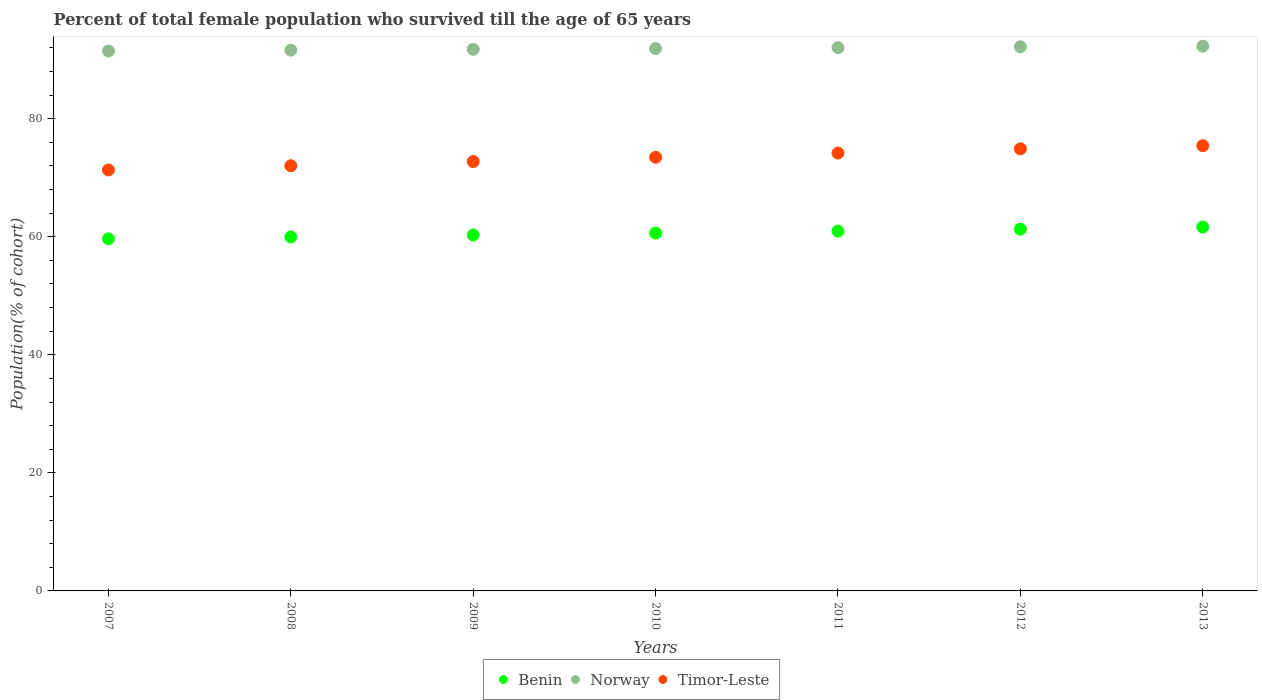What is the percentage of total female population who survived till the age of 65 years in Norway in 2009?
Keep it short and to the point. 91.76. Across all years, what is the maximum percentage of total female population who survived till the age of 65 years in Benin?
Give a very brief answer. 61.65. Across all years, what is the minimum percentage of total female population who survived till the age of 65 years in Norway?
Provide a succinct answer. 91.47. In which year was the percentage of total female population who survived till the age of 65 years in Norway maximum?
Keep it short and to the point. 2013. What is the total percentage of total female population who survived till the age of 65 years in Norway in the graph?
Ensure brevity in your answer.  643.25. What is the difference between the percentage of total female population who survived till the age of 65 years in Norway in 2007 and that in 2012?
Provide a short and direct response. -0.71. What is the difference between the percentage of total female population who survived till the age of 65 years in Benin in 2011 and the percentage of total female population who survived till the age of 65 years in Norway in 2012?
Your answer should be very brief. -31.23. What is the average percentage of total female population who survived till the age of 65 years in Timor-Leste per year?
Ensure brevity in your answer.  73.44. In the year 2008, what is the difference between the percentage of total female population who survived till the age of 65 years in Timor-Leste and percentage of total female population who survived till the age of 65 years in Norway?
Keep it short and to the point. -19.58. What is the ratio of the percentage of total female population who survived till the age of 65 years in Timor-Leste in 2012 to that in 2013?
Offer a terse response. 0.99. Is the difference between the percentage of total female population who survived till the age of 65 years in Timor-Leste in 2009 and 2013 greater than the difference between the percentage of total female population who survived till the age of 65 years in Norway in 2009 and 2013?
Your answer should be very brief. No. What is the difference between the highest and the second highest percentage of total female population who survived till the age of 65 years in Norway?
Your answer should be compact. 0.1. What is the difference between the highest and the lowest percentage of total female population who survived till the age of 65 years in Norway?
Keep it short and to the point. 0.81. Is it the case that in every year, the sum of the percentage of total female population who survived till the age of 65 years in Norway and percentage of total female population who survived till the age of 65 years in Timor-Leste  is greater than the percentage of total female population who survived till the age of 65 years in Benin?
Provide a short and direct response. Yes. Does the percentage of total female population who survived till the age of 65 years in Norway monotonically increase over the years?
Offer a terse response. Yes. Is the percentage of total female population who survived till the age of 65 years in Norway strictly greater than the percentage of total female population who survived till the age of 65 years in Benin over the years?
Your answer should be compact. Yes. Is the percentage of total female population who survived till the age of 65 years in Timor-Leste strictly less than the percentage of total female population who survived till the age of 65 years in Norway over the years?
Provide a succinct answer. Yes. How many dotlines are there?
Your answer should be very brief. 3. Where does the legend appear in the graph?
Provide a succinct answer. Bottom center. What is the title of the graph?
Offer a very short reply. Percent of total female population who survived till the age of 65 years. What is the label or title of the X-axis?
Offer a very short reply. Years. What is the label or title of the Y-axis?
Offer a terse response. Population(% of cohort). What is the Population(% of cohort) in Benin in 2007?
Your answer should be compact. 59.65. What is the Population(% of cohort) of Norway in 2007?
Provide a succinct answer. 91.47. What is the Population(% of cohort) in Timor-Leste in 2007?
Provide a succinct answer. 71.32. What is the Population(% of cohort) of Benin in 2008?
Your response must be concise. 59.98. What is the Population(% of cohort) in Norway in 2008?
Offer a terse response. 91.61. What is the Population(% of cohort) of Timor-Leste in 2008?
Provide a short and direct response. 72.03. What is the Population(% of cohort) in Benin in 2009?
Give a very brief answer. 60.3. What is the Population(% of cohort) in Norway in 2009?
Keep it short and to the point. 91.76. What is the Population(% of cohort) in Timor-Leste in 2009?
Your answer should be very brief. 72.75. What is the Population(% of cohort) of Benin in 2010?
Provide a succinct answer. 60.63. What is the Population(% of cohort) of Norway in 2010?
Your answer should be very brief. 91.9. What is the Population(% of cohort) in Timor-Leste in 2010?
Ensure brevity in your answer.  73.46. What is the Population(% of cohort) of Benin in 2011?
Your response must be concise. 60.95. What is the Population(% of cohort) of Norway in 2011?
Offer a terse response. 92.04. What is the Population(% of cohort) in Timor-Leste in 2011?
Give a very brief answer. 74.18. What is the Population(% of cohort) in Benin in 2012?
Give a very brief answer. 61.28. What is the Population(% of cohort) of Norway in 2012?
Offer a terse response. 92.18. What is the Population(% of cohort) of Timor-Leste in 2012?
Your answer should be compact. 74.9. What is the Population(% of cohort) in Benin in 2013?
Keep it short and to the point. 61.65. What is the Population(% of cohort) in Norway in 2013?
Ensure brevity in your answer.  92.28. What is the Population(% of cohort) in Timor-Leste in 2013?
Offer a very short reply. 75.43. Across all years, what is the maximum Population(% of cohort) in Benin?
Your answer should be very brief. 61.65. Across all years, what is the maximum Population(% of cohort) in Norway?
Your response must be concise. 92.28. Across all years, what is the maximum Population(% of cohort) of Timor-Leste?
Provide a succinct answer. 75.43. Across all years, what is the minimum Population(% of cohort) in Benin?
Ensure brevity in your answer.  59.65. Across all years, what is the minimum Population(% of cohort) of Norway?
Your response must be concise. 91.47. Across all years, what is the minimum Population(% of cohort) of Timor-Leste?
Provide a succinct answer. 71.32. What is the total Population(% of cohort) of Benin in the graph?
Make the answer very short. 424.44. What is the total Population(% of cohort) of Norway in the graph?
Keep it short and to the point. 643.25. What is the total Population(% of cohort) of Timor-Leste in the graph?
Your answer should be compact. 514.07. What is the difference between the Population(% of cohort) in Benin in 2007 and that in 2008?
Provide a succinct answer. -0.33. What is the difference between the Population(% of cohort) in Norway in 2007 and that in 2008?
Make the answer very short. -0.14. What is the difference between the Population(% of cohort) of Timor-Leste in 2007 and that in 2008?
Provide a short and direct response. -0.72. What is the difference between the Population(% of cohort) in Benin in 2007 and that in 2009?
Provide a succinct answer. -0.65. What is the difference between the Population(% of cohort) of Norway in 2007 and that in 2009?
Give a very brief answer. -0.28. What is the difference between the Population(% of cohort) in Timor-Leste in 2007 and that in 2009?
Offer a very short reply. -1.43. What is the difference between the Population(% of cohort) of Benin in 2007 and that in 2010?
Your answer should be very brief. -0.98. What is the difference between the Population(% of cohort) of Norway in 2007 and that in 2010?
Provide a succinct answer. -0.43. What is the difference between the Population(% of cohort) of Timor-Leste in 2007 and that in 2010?
Give a very brief answer. -2.15. What is the difference between the Population(% of cohort) of Benin in 2007 and that in 2011?
Offer a very short reply. -1.3. What is the difference between the Population(% of cohort) in Norway in 2007 and that in 2011?
Make the answer very short. -0.57. What is the difference between the Population(% of cohort) of Timor-Leste in 2007 and that in 2011?
Ensure brevity in your answer.  -2.87. What is the difference between the Population(% of cohort) of Benin in 2007 and that in 2012?
Your response must be concise. -1.63. What is the difference between the Population(% of cohort) of Norway in 2007 and that in 2012?
Make the answer very short. -0.71. What is the difference between the Population(% of cohort) of Timor-Leste in 2007 and that in 2012?
Ensure brevity in your answer.  -3.58. What is the difference between the Population(% of cohort) of Benin in 2007 and that in 2013?
Keep it short and to the point. -2. What is the difference between the Population(% of cohort) of Norway in 2007 and that in 2013?
Keep it short and to the point. -0.81. What is the difference between the Population(% of cohort) in Timor-Leste in 2007 and that in 2013?
Provide a short and direct response. -4.11. What is the difference between the Population(% of cohort) of Benin in 2008 and that in 2009?
Your answer should be very brief. -0.33. What is the difference between the Population(% of cohort) of Norway in 2008 and that in 2009?
Make the answer very short. -0.14. What is the difference between the Population(% of cohort) of Timor-Leste in 2008 and that in 2009?
Make the answer very short. -0.72. What is the difference between the Population(% of cohort) of Benin in 2008 and that in 2010?
Provide a succinct answer. -0.65. What is the difference between the Population(% of cohort) of Norway in 2008 and that in 2010?
Keep it short and to the point. -0.28. What is the difference between the Population(% of cohort) in Timor-Leste in 2008 and that in 2010?
Ensure brevity in your answer.  -1.43. What is the difference between the Population(% of cohort) in Benin in 2008 and that in 2011?
Provide a succinct answer. -0.98. What is the difference between the Population(% of cohort) in Norway in 2008 and that in 2011?
Ensure brevity in your answer.  -0.43. What is the difference between the Population(% of cohort) of Timor-Leste in 2008 and that in 2011?
Provide a succinct answer. -2.15. What is the difference between the Population(% of cohort) of Benin in 2008 and that in 2012?
Offer a very short reply. -1.3. What is the difference between the Population(% of cohort) of Norway in 2008 and that in 2012?
Make the answer very short. -0.57. What is the difference between the Population(% of cohort) in Timor-Leste in 2008 and that in 2012?
Your answer should be compact. -2.87. What is the difference between the Population(% of cohort) of Benin in 2008 and that in 2013?
Offer a very short reply. -1.67. What is the difference between the Population(% of cohort) in Norway in 2008 and that in 2013?
Offer a very short reply. -0.67. What is the difference between the Population(% of cohort) of Timor-Leste in 2008 and that in 2013?
Your response must be concise. -3.4. What is the difference between the Population(% of cohort) of Benin in 2009 and that in 2010?
Provide a short and direct response. -0.33. What is the difference between the Population(% of cohort) of Norway in 2009 and that in 2010?
Provide a short and direct response. -0.14. What is the difference between the Population(% of cohort) of Timor-Leste in 2009 and that in 2010?
Provide a succinct answer. -0.72. What is the difference between the Population(% of cohort) of Benin in 2009 and that in 2011?
Provide a short and direct response. -0.65. What is the difference between the Population(% of cohort) in Norway in 2009 and that in 2011?
Your answer should be very brief. -0.28. What is the difference between the Population(% of cohort) of Timor-Leste in 2009 and that in 2011?
Your answer should be very brief. -1.43. What is the difference between the Population(% of cohort) of Benin in 2009 and that in 2012?
Offer a terse response. -0.98. What is the difference between the Population(% of cohort) of Norway in 2009 and that in 2012?
Keep it short and to the point. -0.43. What is the difference between the Population(% of cohort) of Timor-Leste in 2009 and that in 2012?
Offer a terse response. -2.15. What is the difference between the Population(% of cohort) in Benin in 2009 and that in 2013?
Make the answer very short. -1.34. What is the difference between the Population(% of cohort) of Norway in 2009 and that in 2013?
Give a very brief answer. -0.53. What is the difference between the Population(% of cohort) of Timor-Leste in 2009 and that in 2013?
Provide a short and direct response. -2.68. What is the difference between the Population(% of cohort) of Benin in 2010 and that in 2011?
Your response must be concise. -0.33. What is the difference between the Population(% of cohort) in Norway in 2010 and that in 2011?
Provide a succinct answer. -0.14. What is the difference between the Population(% of cohort) in Timor-Leste in 2010 and that in 2011?
Offer a very short reply. -0.72. What is the difference between the Population(% of cohort) of Benin in 2010 and that in 2012?
Offer a very short reply. -0.65. What is the difference between the Population(% of cohort) in Norway in 2010 and that in 2012?
Your answer should be very brief. -0.28. What is the difference between the Population(% of cohort) in Timor-Leste in 2010 and that in 2012?
Your answer should be compact. -1.43. What is the difference between the Population(% of cohort) of Benin in 2010 and that in 2013?
Give a very brief answer. -1.02. What is the difference between the Population(% of cohort) of Norway in 2010 and that in 2013?
Your response must be concise. -0.39. What is the difference between the Population(% of cohort) of Timor-Leste in 2010 and that in 2013?
Make the answer very short. -1.96. What is the difference between the Population(% of cohort) in Benin in 2011 and that in 2012?
Make the answer very short. -0.33. What is the difference between the Population(% of cohort) in Norway in 2011 and that in 2012?
Provide a succinct answer. -0.14. What is the difference between the Population(% of cohort) in Timor-Leste in 2011 and that in 2012?
Offer a very short reply. -0.72. What is the difference between the Population(% of cohort) in Benin in 2011 and that in 2013?
Ensure brevity in your answer.  -0.69. What is the difference between the Population(% of cohort) of Norway in 2011 and that in 2013?
Offer a terse response. -0.24. What is the difference between the Population(% of cohort) of Timor-Leste in 2011 and that in 2013?
Ensure brevity in your answer.  -1.25. What is the difference between the Population(% of cohort) in Benin in 2012 and that in 2013?
Keep it short and to the point. -0.37. What is the difference between the Population(% of cohort) of Norway in 2012 and that in 2013?
Give a very brief answer. -0.1. What is the difference between the Population(% of cohort) of Timor-Leste in 2012 and that in 2013?
Provide a succinct answer. -0.53. What is the difference between the Population(% of cohort) in Benin in 2007 and the Population(% of cohort) in Norway in 2008?
Ensure brevity in your answer.  -31.96. What is the difference between the Population(% of cohort) of Benin in 2007 and the Population(% of cohort) of Timor-Leste in 2008?
Provide a succinct answer. -12.38. What is the difference between the Population(% of cohort) of Norway in 2007 and the Population(% of cohort) of Timor-Leste in 2008?
Your answer should be compact. 19.44. What is the difference between the Population(% of cohort) in Benin in 2007 and the Population(% of cohort) in Norway in 2009?
Provide a short and direct response. -32.11. What is the difference between the Population(% of cohort) of Benin in 2007 and the Population(% of cohort) of Timor-Leste in 2009?
Provide a succinct answer. -13.1. What is the difference between the Population(% of cohort) in Norway in 2007 and the Population(% of cohort) in Timor-Leste in 2009?
Your response must be concise. 18.72. What is the difference between the Population(% of cohort) of Benin in 2007 and the Population(% of cohort) of Norway in 2010?
Give a very brief answer. -32.25. What is the difference between the Population(% of cohort) of Benin in 2007 and the Population(% of cohort) of Timor-Leste in 2010?
Ensure brevity in your answer.  -13.81. What is the difference between the Population(% of cohort) in Norway in 2007 and the Population(% of cohort) in Timor-Leste in 2010?
Your answer should be very brief. 18.01. What is the difference between the Population(% of cohort) in Benin in 2007 and the Population(% of cohort) in Norway in 2011?
Provide a succinct answer. -32.39. What is the difference between the Population(% of cohort) of Benin in 2007 and the Population(% of cohort) of Timor-Leste in 2011?
Provide a short and direct response. -14.53. What is the difference between the Population(% of cohort) of Norway in 2007 and the Population(% of cohort) of Timor-Leste in 2011?
Your answer should be compact. 17.29. What is the difference between the Population(% of cohort) of Benin in 2007 and the Population(% of cohort) of Norway in 2012?
Your response must be concise. -32.53. What is the difference between the Population(% of cohort) of Benin in 2007 and the Population(% of cohort) of Timor-Leste in 2012?
Your answer should be compact. -15.25. What is the difference between the Population(% of cohort) of Norway in 2007 and the Population(% of cohort) of Timor-Leste in 2012?
Your answer should be very brief. 16.57. What is the difference between the Population(% of cohort) in Benin in 2007 and the Population(% of cohort) in Norway in 2013?
Your answer should be very brief. -32.63. What is the difference between the Population(% of cohort) of Benin in 2007 and the Population(% of cohort) of Timor-Leste in 2013?
Make the answer very short. -15.78. What is the difference between the Population(% of cohort) in Norway in 2007 and the Population(% of cohort) in Timor-Leste in 2013?
Provide a short and direct response. 16.04. What is the difference between the Population(% of cohort) of Benin in 2008 and the Population(% of cohort) of Norway in 2009?
Provide a short and direct response. -31.78. What is the difference between the Population(% of cohort) in Benin in 2008 and the Population(% of cohort) in Timor-Leste in 2009?
Your answer should be compact. -12.77. What is the difference between the Population(% of cohort) in Norway in 2008 and the Population(% of cohort) in Timor-Leste in 2009?
Your response must be concise. 18.87. What is the difference between the Population(% of cohort) of Benin in 2008 and the Population(% of cohort) of Norway in 2010?
Offer a terse response. -31.92. What is the difference between the Population(% of cohort) of Benin in 2008 and the Population(% of cohort) of Timor-Leste in 2010?
Offer a very short reply. -13.49. What is the difference between the Population(% of cohort) of Norway in 2008 and the Population(% of cohort) of Timor-Leste in 2010?
Provide a succinct answer. 18.15. What is the difference between the Population(% of cohort) of Benin in 2008 and the Population(% of cohort) of Norway in 2011?
Your response must be concise. -32.06. What is the difference between the Population(% of cohort) of Benin in 2008 and the Population(% of cohort) of Timor-Leste in 2011?
Provide a succinct answer. -14.21. What is the difference between the Population(% of cohort) in Norway in 2008 and the Population(% of cohort) in Timor-Leste in 2011?
Your answer should be very brief. 17.43. What is the difference between the Population(% of cohort) in Benin in 2008 and the Population(% of cohort) in Norway in 2012?
Keep it short and to the point. -32.21. What is the difference between the Population(% of cohort) of Benin in 2008 and the Population(% of cohort) of Timor-Leste in 2012?
Offer a very short reply. -14.92. What is the difference between the Population(% of cohort) of Norway in 2008 and the Population(% of cohort) of Timor-Leste in 2012?
Your answer should be compact. 16.72. What is the difference between the Population(% of cohort) of Benin in 2008 and the Population(% of cohort) of Norway in 2013?
Your answer should be compact. -32.31. What is the difference between the Population(% of cohort) of Benin in 2008 and the Population(% of cohort) of Timor-Leste in 2013?
Offer a terse response. -15.45. What is the difference between the Population(% of cohort) of Norway in 2008 and the Population(% of cohort) of Timor-Leste in 2013?
Provide a short and direct response. 16.19. What is the difference between the Population(% of cohort) in Benin in 2009 and the Population(% of cohort) in Norway in 2010?
Offer a terse response. -31.6. What is the difference between the Population(% of cohort) in Benin in 2009 and the Population(% of cohort) in Timor-Leste in 2010?
Your answer should be very brief. -13.16. What is the difference between the Population(% of cohort) of Norway in 2009 and the Population(% of cohort) of Timor-Leste in 2010?
Ensure brevity in your answer.  18.29. What is the difference between the Population(% of cohort) of Benin in 2009 and the Population(% of cohort) of Norway in 2011?
Make the answer very short. -31.74. What is the difference between the Population(% of cohort) in Benin in 2009 and the Population(% of cohort) in Timor-Leste in 2011?
Ensure brevity in your answer.  -13.88. What is the difference between the Population(% of cohort) of Norway in 2009 and the Population(% of cohort) of Timor-Leste in 2011?
Give a very brief answer. 17.57. What is the difference between the Population(% of cohort) of Benin in 2009 and the Population(% of cohort) of Norway in 2012?
Your response must be concise. -31.88. What is the difference between the Population(% of cohort) in Benin in 2009 and the Population(% of cohort) in Timor-Leste in 2012?
Provide a succinct answer. -14.6. What is the difference between the Population(% of cohort) in Norway in 2009 and the Population(% of cohort) in Timor-Leste in 2012?
Keep it short and to the point. 16.86. What is the difference between the Population(% of cohort) of Benin in 2009 and the Population(% of cohort) of Norway in 2013?
Your response must be concise. -31.98. What is the difference between the Population(% of cohort) in Benin in 2009 and the Population(% of cohort) in Timor-Leste in 2013?
Give a very brief answer. -15.13. What is the difference between the Population(% of cohort) in Norway in 2009 and the Population(% of cohort) in Timor-Leste in 2013?
Make the answer very short. 16.33. What is the difference between the Population(% of cohort) of Benin in 2010 and the Population(% of cohort) of Norway in 2011?
Make the answer very short. -31.41. What is the difference between the Population(% of cohort) of Benin in 2010 and the Population(% of cohort) of Timor-Leste in 2011?
Your answer should be very brief. -13.55. What is the difference between the Population(% of cohort) in Norway in 2010 and the Population(% of cohort) in Timor-Leste in 2011?
Ensure brevity in your answer.  17.72. What is the difference between the Population(% of cohort) of Benin in 2010 and the Population(% of cohort) of Norway in 2012?
Offer a terse response. -31.55. What is the difference between the Population(% of cohort) of Benin in 2010 and the Population(% of cohort) of Timor-Leste in 2012?
Keep it short and to the point. -14.27. What is the difference between the Population(% of cohort) of Norway in 2010 and the Population(% of cohort) of Timor-Leste in 2012?
Your answer should be very brief. 17. What is the difference between the Population(% of cohort) in Benin in 2010 and the Population(% of cohort) in Norway in 2013?
Your answer should be very brief. -31.66. What is the difference between the Population(% of cohort) in Benin in 2010 and the Population(% of cohort) in Timor-Leste in 2013?
Provide a succinct answer. -14.8. What is the difference between the Population(% of cohort) of Norway in 2010 and the Population(% of cohort) of Timor-Leste in 2013?
Your response must be concise. 16.47. What is the difference between the Population(% of cohort) of Benin in 2011 and the Population(% of cohort) of Norway in 2012?
Provide a succinct answer. -31.23. What is the difference between the Population(% of cohort) of Benin in 2011 and the Population(% of cohort) of Timor-Leste in 2012?
Offer a terse response. -13.94. What is the difference between the Population(% of cohort) of Norway in 2011 and the Population(% of cohort) of Timor-Leste in 2012?
Keep it short and to the point. 17.14. What is the difference between the Population(% of cohort) of Benin in 2011 and the Population(% of cohort) of Norway in 2013?
Your response must be concise. -31.33. What is the difference between the Population(% of cohort) in Benin in 2011 and the Population(% of cohort) in Timor-Leste in 2013?
Give a very brief answer. -14.47. What is the difference between the Population(% of cohort) in Norway in 2011 and the Population(% of cohort) in Timor-Leste in 2013?
Provide a succinct answer. 16.61. What is the difference between the Population(% of cohort) in Benin in 2012 and the Population(% of cohort) in Norway in 2013?
Offer a very short reply. -31. What is the difference between the Population(% of cohort) of Benin in 2012 and the Population(% of cohort) of Timor-Leste in 2013?
Keep it short and to the point. -14.15. What is the difference between the Population(% of cohort) of Norway in 2012 and the Population(% of cohort) of Timor-Leste in 2013?
Keep it short and to the point. 16.75. What is the average Population(% of cohort) of Benin per year?
Offer a very short reply. 60.63. What is the average Population(% of cohort) in Norway per year?
Your answer should be very brief. 91.89. What is the average Population(% of cohort) of Timor-Leste per year?
Your answer should be compact. 73.44. In the year 2007, what is the difference between the Population(% of cohort) of Benin and Population(% of cohort) of Norway?
Your response must be concise. -31.82. In the year 2007, what is the difference between the Population(% of cohort) of Benin and Population(% of cohort) of Timor-Leste?
Provide a short and direct response. -11.67. In the year 2007, what is the difference between the Population(% of cohort) of Norway and Population(% of cohort) of Timor-Leste?
Provide a succinct answer. 20.16. In the year 2008, what is the difference between the Population(% of cohort) in Benin and Population(% of cohort) in Norway?
Offer a terse response. -31.64. In the year 2008, what is the difference between the Population(% of cohort) in Benin and Population(% of cohort) in Timor-Leste?
Give a very brief answer. -12.06. In the year 2008, what is the difference between the Population(% of cohort) in Norway and Population(% of cohort) in Timor-Leste?
Offer a terse response. 19.58. In the year 2009, what is the difference between the Population(% of cohort) in Benin and Population(% of cohort) in Norway?
Offer a very short reply. -31.45. In the year 2009, what is the difference between the Population(% of cohort) in Benin and Population(% of cohort) in Timor-Leste?
Keep it short and to the point. -12.45. In the year 2009, what is the difference between the Population(% of cohort) of Norway and Population(% of cohort) of Timor-Leste?
Make the answer very short. 19.01. In the year 2010, what is the difference between the Population(% of cohort) in Benin and Population(% of cohort) in Norway?
Ensure brevity in your answer.  -31.27. In the year 2010, what is the difference between the Population(% of cohort) in Benin and Population(% of cohort) in Timor-Leste?
Offer a very short reply. -12.84. In the year 2010, what is the difference between the Population(% of cohort) of Norway and Population(% of cohort) of Timor-Leste?
Your response must be concise. 18.43. In the year 2011, what is the difference between the Population(% of cohort) of Benin and Population(% of cohort) of Norway?
Your answer should be very brief. -31.09. In the year 2011, what is the difference between the Population(% of cohort) in Benin and Population(% of cohort) in Timor-Leste?
Your answer should be very brief. -13.23. In the year 2011, what is the difference between the Population(% of cohort) of Norway and Population(% of cohort) of Timor-Leste?
Provide a succinct answer. 17.86. In the year 2012, what is the difference between the Population(% of cohort) of Benin and Population(% of cohort) of Norway?
Provide a short and direct response. -30.9. In the year 2012, what is the difference between the Population(% of cohort) of Benin and Population(% of cohort) of Timor-Leste?
Keep it short and to the point. -13.62. In the year 2012, what is the difference between the Population(% of cohort) in Norway and Population(% of cohort) in Timor-Leste?
Your response must be concise. 17.29. In the year 2013, what is the difference between the Population(% of cohort) of Benin and Population(% of cohort) of Norway?
Give a very brief answer. -30.64. In the year 2013, what is the difference between the Population(% of cohort) in Benin and Population(% of cohort) in Timor-Leste?
Offer a very short reply. -13.78. In the year 2013, what is the difference between the Population(% of cohort) of Norway and Population(% of cohort) of Timor-Leste?
Your answer should be very brief. 16.86. What is the ratio of the Population(% of cohort) in Benin in 2007 to that in 2009?
Ensure brevity in your answer.  0.99. What is the ratio of the Population(% of cohort) of Norway in 2007 to that in 2009?
Your answer should be compact. 1. What is the ratio of the Population(% of cohort) of Timor-Leste in 2007 to that in 2009?
Give a very brief answer. 0.98. What is the ratio of the Population(% of cohort) of Benin in 2007 to that in 2010?
Offer a terse response. 0.98. What is the ratio of the Population(% of cohort) of Timor-Leste in 2007 to that in 2010?
Give a very brief answer. 0.97. What is the ratio of the Population(% of cohort) of Benin in 2007 to that in 2011?
Your answer should be very brief. 0.98. What is the ratio of the Population(% of cohort) of Timor-Leste in 2007 to that in 2011?
Your answer should be compact. 0.96. What is the ratio of the Population(% of cohort) in Benin in 2007 to that in 2012?
Offer a very short reply. 0.97. What is the ratio of the Population(% of cohort) in Timor-Leste in 2007 to that in 2012?
Provide a short and direct response. 0.95. What is the ratio of the Population(% of cohort) of Benin in 2007 to that in 2013?
Your answer should be compact. 0.97. What is the ratio of the Population(% of cohort) in Timor-Leste in 2007 to that in 2013?
Offer a very short reply. 0.95. What is the ratio of the Population(% of cohort) in Timor-Leste in 2008 to that in 2009?
Ensure brevity in your answer.  0.99. What is the ratio of the Population(% of cohort) of Timor-Leste in 2008 to that in 2010?
Your answer should be very brief. 0.98. What is the ratio of the Population(% of cohort) in Timor-Leste in 2008 to that in 2011?
Your answer should be compact. 0.97. What is the ratio of the Population(% of cohort) in Benin in 2008 to that in 2012?
Provide a succinct answer. 0.98. What is the ratio of the Population(% of cohort) of Norway in 2008 to that in 2012?
Make the answer very short. 0.99. What is the ratio of the Population(% of cohort) in Timor-Leste in 2008 to that in 2012?
Offer a terse response. 0.96. What is the ratio of the Population(% of cohort) of Benin in 2008 to that in 2013?
Provide a short and direct response. 0.97. What is the ratio of the Population(% of cohort) of Norway in 2008 to that in 2013?
Make the answer very short. 0.99. What is the ratio of the Population(% of cohort) in Timor-Leste in 2008 to that in 2013?
Give a very brief answer. 0.95. What is the ratio of the Population(% of cohort) of Benin in 2009 to that in 2010?
Give a very brief answer. 0.99. What is the ratio of the Population(% of cohort) in Norway in 2009 to that in 2010?
Provide a short and direct response. 1. What is the ratio of the Population(% of cohort) of Timor-Leste in 2009 to that in 2010?
Make the answer very short. 0.99. What is the ratio of the Population(% of cohort) in Benin in 2009 to that in 2011?
Keep it short and to the point. 0.99. What is the ratio of the Population(% of cohort) in Timor-Leste in 2009 to that in 2011?
Provide a succinct answer. 0.98. What is the ratio of the Population(% of cohort) in Norway in 2009 to that in 2012?
Ensure brevity in your answer.  1. What is the ratio of the Population(% of cohort) of Timor-Leste in 2009 to that in 2012?
Offer a terse response. 0.97. What is the ratio of the Population(% of cohort) in Benin in 2009 to that in 2013?
Ensure brevity in your answer.  0.98. What is the ratio of the Population(% of cohort) in Timor-Leste in 2009 to that in 2013?
Offer a very short reply. 0.96. What is the ratio of the Population(% of cohort) in Benin in 2010 to that in 2011?
Provide a short and direct response. 0.99. What is the ratio of the Population(% of cohort) in Timor-Leste in 2010 to that in 2011?
Offer a very short reply. 0.99. What is the ratio of the Population(% of cohort) in Norway in 2010 to that in 2012?
Give a very brief answer. 1. What is the ratio of the Population(% of cohort) in Timor-Leste in 2010 to that in 2012?
Provide a succinct answer. 0.98. What is the ratio of the Population(% of cohort) in Benin in 2010 to that in 2013?
Offer a terse response. 0.98. What is the ratio of the Population(% of cohort) of Norway in 2010 to that in 2013?
Keep it short and to the point. 1. What is the ratio of the Population(% of cohort) of Timor-Leste in 2010 to that in 2013?
Your answer should be very brief. 0.97. What is the ratio of the Population(% of cohort) of Benin in 2011 to that in 2012?
Give a very brief answer. 0.99. What is the ratio of the Population(% of cohort) of Benin in 2011 to that in 2013?
Make the answer very short. 0.99. What is the ratio of the Population(% of cohort) of Timor-Leste in 2011 to that in 2013?
Your answer should be very brief. 0.98. What is the ratio of the Population(% of cohort) in Benin in 2012 to that in 2013?
Ensure brevity in your answer.  0.99. What is the difference between the highest and the second highest Population(% of cohort) of Benin?
Offer a terse response. 0.37. What is the difference between the highest and the second highest Population(% of cohort) of Norway?
Offer a very short reply. 0.1. What is the difference between the highest and the second highest Population(% of cohort) in Timor-Leste?
Provide a short and direct response. 0.53. What is the difference between the highest and the lowest Population(% of cohort) of Benin?
Keep it short and to the point. 2. What is the difference between the highest and the lowest Population(% of cohort) of Norway?
Provide a short and direct response. 0.81. What is the difference between the highest and the lowest Population(% of cohort) of Timor-Leste?
Ensure brevity in your answer.  4.11. 